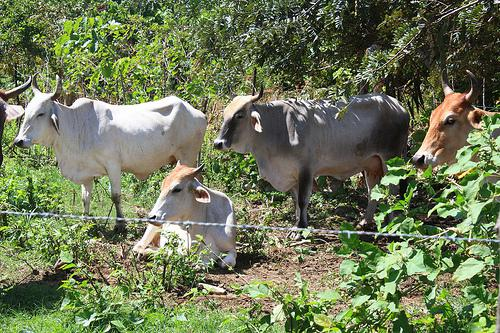Question: what kind of animal are these?
Choices:
A. Cows.
B. Horses.
C. Sheep.
D. Dogs.
Answer with the letter. Answer: A Question: how many cows can be seen?
Choices:
A. Five.
B. One.
C. Two.
D. No cows.
Answer with the letter. Answer: A Question: where is the metal wire?
Choices:
A. In front of the cows.
B. On the fence post.
C. Above the fence.
D. Around the pen.
Answer with the letter. Answer: A Question: what doe the cows have on their heads?
Choices:
A. Two horns.
B. Hats.
C. Hair.
D. Ears.
Answer with the letter. Answer: A Question: where are the cows looking?
Choices:
A. To the right.
B. To the left.
C. Up.
D. Down.
Answer with the letter. Answer: B 